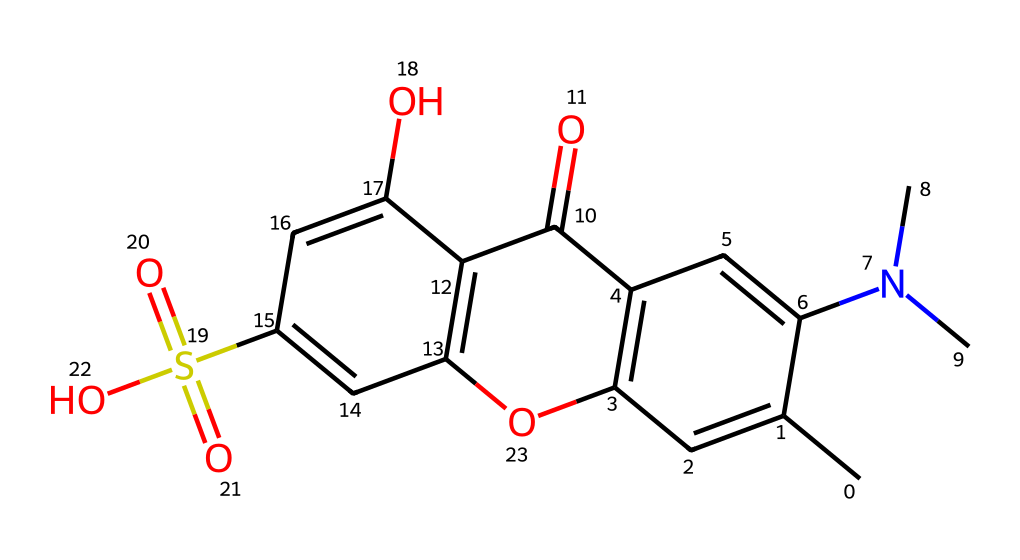What is the total number of carbon atoms in this chemical? By analyzing the SMILES representation, we can count the carbon atoms represented. Each 'C' denotes a carbon atom. Upon examining the SMILES, there are a total of 15 carbon atoms present.
Answer: 15 How many hydroxyl (–OH) groups are present in the structure? In the SMILES representation, the presence of ‘O’ connected with ‘H’ indicates hydroxyl groups. There are two –OH groups visible in the structure when we analyze the representation.
Answer: 2 Identify one functional group in this compound. Looking at the structure, we can identify the sulfonic acid functional group characterized by ‘S(=O)(=O)O’ in the SMILES. This part represents a sulfur atom bonded to three oxygen atoms, indicating it is a sulfonic acid.
Answer: sulfonic acid Which part of the molecule contributes to its photoreactivity? Photoreactivity often arises from the presence of a conjugated system or chromophore within the molecule, which can be identified by the alternating double bonds present. This compound contains multiple conjugated rings with double bonds and substituents that enhance its photoreactive properties.
Answer: conjugated system What is the total number of nitrogen atoms in this chemical? In the SMILES, the presence of 'N' indicates nitrogen atoms. There is one 'N' visible in the structure, thus it contains a total of one nitrogen atom.
Answer: 1 Does this compound contain any aromatic rings? Aromatic rings are characterized by alternating double bonds and are usually depicted with cyclic structures; upon reviewing the structure, there are two distinct aromatic systems present, as indicated by the presence of cycles with alternating double bonds.
Answer: yes What type of chemical characterizes fluorescent dyes like this compound? Fluorescent dyes are typically characterized by their ability to absorb ultraviolet light and emit visible light; in this compound, the presence of multiple conjugated systems contributes to its fluorescent properties, allowing it to exhibit such behavior when exposed to UV light.
Answer: conjugated systems 